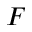<formula> <loc_0><loc_0><loc_500><loc_500>F</formula> 